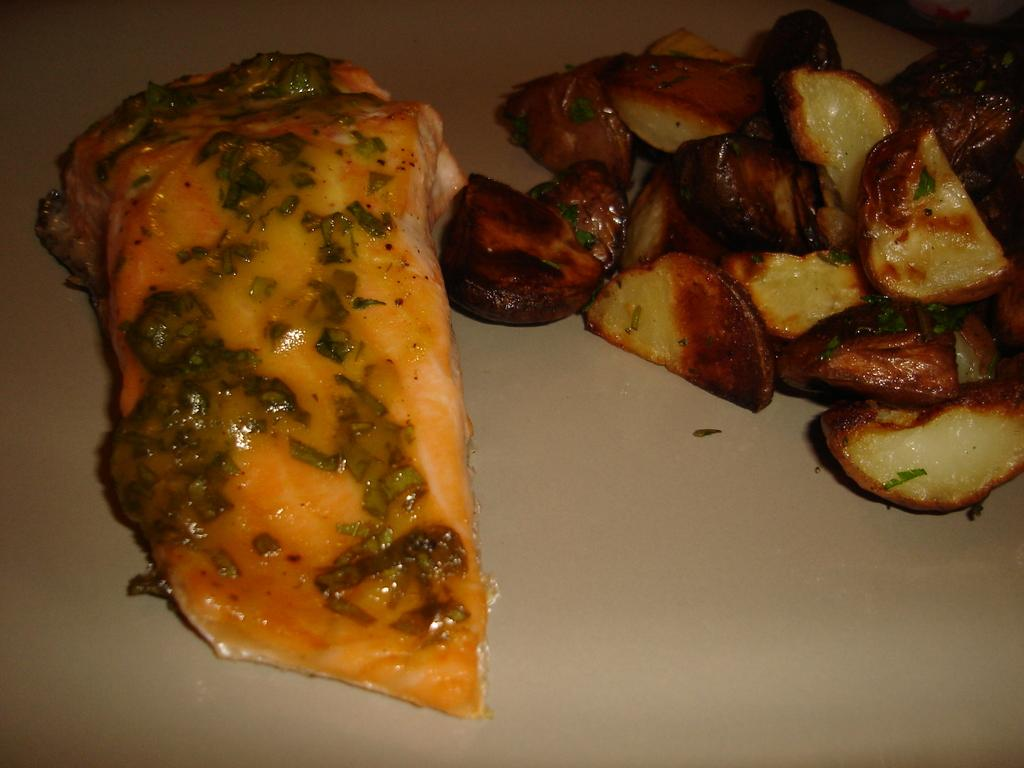What is present in the image related to food? There are food pieces in the image. How are the food pieces arranged or contained? The food pieces are in a plate. How many brothers are sitting on the cushion near the sea in the image? There is no mention of brothers, cushions, or the sea in the image; it only features food pieces in a plate. 